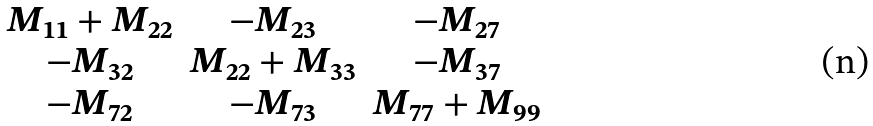Convert formula to latex. <formula><loc_0><loc_0><loc_500><loc_500>\begin{matrix} M _ { 1 1 } + M _ { 2 2 } & - M _ { 2 3 } & - M _ { 2 7 } \\ - M _ { 3 2 } & M _ { 2 2 } + M _ { 3 3 } & - M _ { 3 7 } \\ - M _ { 7 2 } & - M _ { 7 3 } & M _ { 7 7 } + M _ { 9 9 } \\ \end{matrix}</formula> 